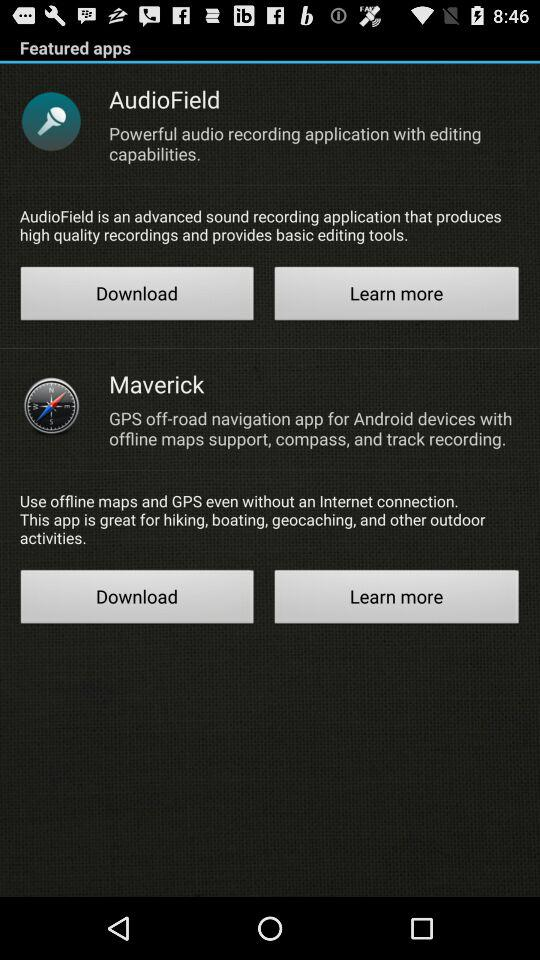What are the features of AudioField? The features of AudioField are "Powerful audio recording application with editing capabilities". 